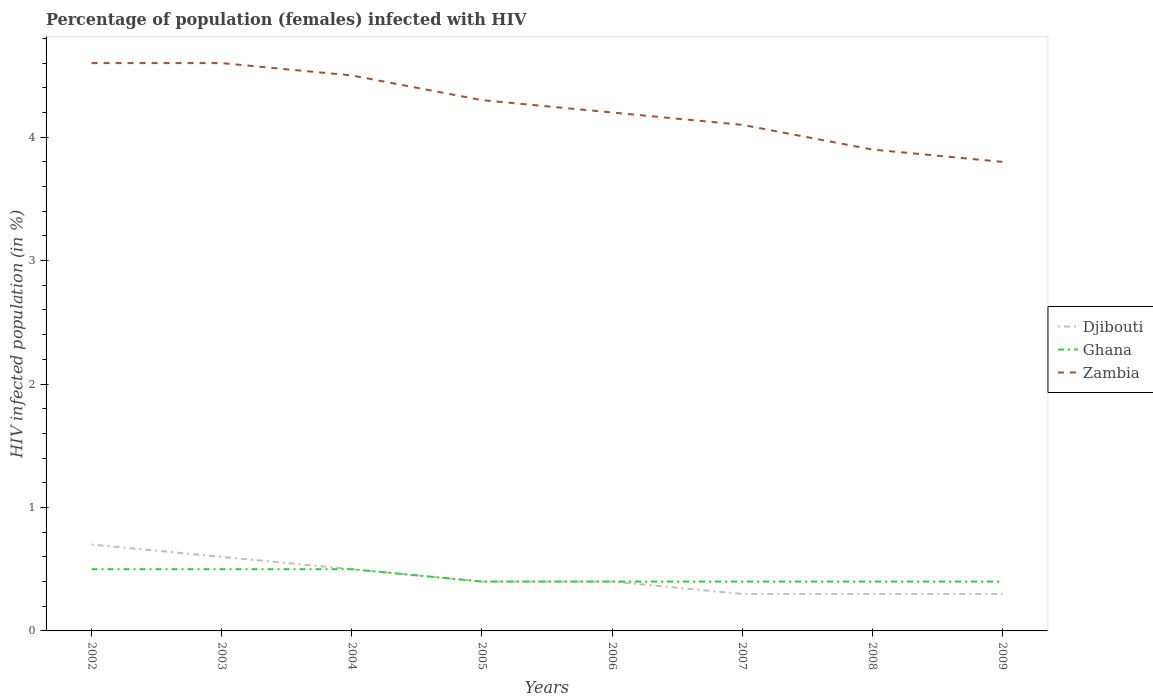How many different coloured lines are there?
Keep it short and to the point. 3. Across all years, what is the maximum percentage of HIV infected female population in Djibouti?
Offer a terse response. 0.3. What is the total percentage of HIV infected female population in Ghana in the graph?
Your response must be concise. 0. What is the difference between the highest and the second highest percentage of HIV infected female population in Djibouti?
Your answer should be very brief. 0.4. Is the percentage of HIV infected female population in Djibouti strictly greater than the percentage of HIV infected female population in Zambia over the years?
Offer a terse response. Yes. Are the values on the major ticks of Y-axis written in scientific E-notation?
Provide a short and direct response. No. What is the title of the graph?
Make the answer very short. Percentage of population (females) infected with HIV. Does "Kuwait" appear as one of the legend labels in the graph?
Make the answer very short. No. What is the label or title of the X-axis?
Give a very brief answer. Years. What is the label or title of the Y-axis?
Keep it short and to the point. HIV infected population (in %). What is the HIV infected population (in %) of Djibouti in 2002?
Your answer should be very brief. 0.7. What is the HIV infected population (in %) of Djibouti in 2003?
Provide a short and direct response. 0.6. What is the HIV infected population (in %) in Ghana in 2003?
Offer a terse response. 0.5. What is the HIV infected population (in %) of Ghana in 2004?
Ensure brevity in your answer.  0.5. What is the HIV infected population (in %) in Djibouti in 2005?
Give a very brief answer. 0.4. What is the HIV infected population (in %) of Ghana in 2006?
Keep it short and to the point. 0.4. What is the HIV infected population (in %) in Djibouti in 2007?
Offer a very short reply. 0.3. What is the HIV infected population (in %) in Ghana in 2007?
Keep it short and to the point. 0.4. What is the HIV infected population (in %) in Zambia in 2007?
Provide a short and direct response. 4.1. What is the HIV infected population (in %) of Djibouti in 2008?
Provide a short and direct response. 0.3. What is the HIV infected population (in %) of Djibouti in 2009?
Ensure brevity in your answer.  0.3. Across all years, what is the maximum HIV infected population (in %) of Djibouti?
Give a very brief answer. 0.7. Across all years, what is the maximum HIV infected population (in %) of Ghana?
Give a very brief answer. 0.5. Across all years, what is the minimum HIV infected population (in %) in Zambia?
Make the answer very short. 3.8. What is the total HIV infected population (in %) of Djibouti in the graph?
Offer a very short reply. 3.5. What is the total HIV infected population (in %) of Ghana in the graph?
Your answer should be very brief. 3.5. What is the total HIV infected population (in %) of Zambia in the graph?
Your answer should be compact. 34. What is the difference between the HIV infected population (in %) in Ghana in 2002 and that in 2003?
Give a very brief answer. 0. What is the difference between the HIV infected population (in %) of Zambia in 2002 and that in 2003?
Your response must be concise. 0. What is the difference between the HIV infected population (in %) in Ghana in 2002 and that in 2004?
Your response must be concise. 0. What is the difference between the HIV infected population (in %) in Zambia in 2002 and that in 2004?
Your answer should be compact. 0.1. What is the difference between the HIV infected population (in %) of Zambia in 2002 and that in 2005?
Ensure brevity in your answer.  0.3. What is the difference between the HIV infected population (in %) in Zambia in 2002 and that in 2006?
Offer a very short reply. 0.4. What is the difference between the HIV infected population (in %) of Djibouti in 2002 and that in 2008?
Give a very brief answer. 0.4. What is the difference between the HIV infected population (in %) in Ghana in 2002 and that in 2008?
Your response must be concise. 0.1. What is the difference between the HIV infected population (in %) of Zambia in 2002 and that in 2008?
Offer a very short reply. 0.7. What is the difference between the HIV infected population (in %) of Djibouti in 2002 and that in 2009?
Provide a succinct answer. 0.4. What is the difference between the HIV infected population (in %) of Ghana in 2002 and that in 2009?
Your answer should be compact. 0.1. What is the difference between the HIV infected population (in %) of Zambia in 2002 and that in 2009?
Your response must be concise. 0.8. What is the difference between the HIV infected population (in %) of Djibouti in 2003 and that in 2005?
Your answer should be very brief. 0.2. What is the difference between the HIV infected population (in %) in Djibouti in 2003 and that in 2006?
Offer a very short reply. 0.2. What is the difference between the HIV infected population (in %) in Zambia in 2003 and that in 2006?
Offer a very short reply. 0.4. What is the difference between the HIV infected population (in %) of Ghana in 2003 and that in 2007?
Provide a succinct answer. 0.1. What is the difference between the HIV infected population (in %) of Zambia in 2003 and that in 2007?
Make the answer very short. 0.5. What is the difference between the HIV infected population (in %) of Djibouti in 2003 and that in 2009?
Give a very brief answer. 0.3. What is the difference between the HIV infected population (in %) of Djibouti in 2004 and that in 2005?
Your answer should be compact. 0.1. What is the difference between the HIV infected population (in %) in Ghana in 2004 and that in 2005?
Your answer should be compact. 0.1. What is the difference between the HIV infected population (in %) of Zambia in 2004 and that in 2005?
Provide a succinct answer. 0.2. What is the difference between the HIV infected population (in %) in Djibouti in 2004 and that in 2006?
Make the answer very short. 0.1. What is the difference between the HIV infected population (in %) of Zambia in 2004 and that in 2006?
Give a very brief answer. 0.3. What is the difference between the HIV infected population (in %) of Zambia in 2004 and that in 2007?
Keep it short and to the point. 0.4. What is the difference between the HIV infected population (in %) of Ghana in 2004 and that in 2008?
Your answer should be compact. 0.1. What is the difference between the HIV infected population (in %) in Zambia in 2004 and that in 2008?
Provide a short and direct response. 0.6. What is the difference between the HIV infected population (in %) of Djibouti in 2005 and that in 2007?
Offer a very short reply. 0.1. What is the difference between the HIV infected population (in %) in Ghana in 2005 and that in 2007?
Make the answer very short. 0. What is the difference between the HIV infected population (in %) in Djibouti in 2005 and that in 2009?
Provide a short and direct response. 0.1. What is the difference between the HIV infected population (in %) of Ghana in 2005 and that in 2009?
Your response must be concise. 0. What is the difference between the HIV infected population (in %) in Djibouti in 2006 and that in 2007?
Your answer should be compact. 0.1. What is the difference between the HIV infected population (in %) in Ghana in 2006 and that in 2007?
Provide a short and direct response. 0. What is the difference between the HIV infected population (in %) in Djibouti in 2006 and that in 2008?
Your answer should be compact. 0.1. What is the difference between the HIV infected population (in %) in Ghana in 2006 and that in 2008?
Provide a succinct answer. 0. What is the difference between the HIV infected population (in %) in Zambia in 2006 and that in 2009?
Provide a short and direct response. 0.4. What is the difference between the HIV infected population (in %) of Djibouti in 2007 and that in 2008?
Provide a short and direct response. 0. What is the difference between the HIV infected population (in %) in Ghana in 2007 and that in 2009?
Make the answer very short. 0. What is the difference between the HIV infected population (in %) in Zambia in 2007 and that in 2009?
Your answer should be compact. 0.3. What is the difference between the HIV infected population (in %) of Djibouti in 2008 and that in 2009?
Your response must be concise. 0. What is the difference between the HIV infected population (in %) of Zambia in 2008 and that in 2009?
Your answer should be compact. 0.1. What is the difference between the HIV infected population (in %) in Ghana in 2002 and the HIV infected population (in %) in Zambia in 2003?
Offer a terse response. -4.1. What is the difference between the HIV infected population (in %) in Djibouti in 2002 and the HIV infected population (in %) in Zambia in 2004?
Offer a terse response. -3.8. What is the difference between the HIV infected population (in %) of Djibouti in 2002 and the HIV infected population (in %) of Zambia in 2005?
Provide a short and direct response. -3.6. What is the difference between the HIV infected population (in %) of Djibouti in 2002 and the HIV infected population (in %) of Ghana in 2006?
Make the answer very short. 0.3. What is the difference between the HIV infected population (in %) in Djibouti in 2002 and the HIV infected population (in %) in Zambia in 2006?
Offer a very short reply. -3.5. What is the difference between the HIV infected population (in %) in Ghana in 2002 and the HIV infected population (in %) in Zambia in 2006?
Provide a short and direct response. -3.7. What is the difference between the HIV infected population (in %) in Djibouti in 2002 and the HIV infected population (in %) in Ghana in 2007?
Keep it short and to the point. 0.3. What is the difference between the HIV infected population (in %) in Ghana in 2002 and the HIV infected population (in %) in Zambia in 2007?
Give a very brief answer. -3.6. What is the difference between the HIV infected population (in %) of Djibouti in 2002 and the HIV infected population (in %) of Zambia in 2009?
Provide a short and direct response. -3.1. What is the difference between the HIV infected population (in %) in Ghana in 2002 and the HIV infected population (in %) in Zambia in 2009?
Keep it short and to the point. -3.3. What is the difference between the HIV infected population (in %) of Djibouti in 2003 and the HIV infected population (in %) of Ghana in 2004?
Offer a terse response. 0.1. What is the difference between the HIV infected population (in %) of Ghana in 2003 and the HIV infected population (in %) of Zambia in 2004?
Offer a very short reply. -4. What is the difference between the HIV infected population (in %) in Djibouti in 2003 and the HIV infected population (in %) in Zambia in 2005?
Offer a very short reply. -3.7. What is the difference between the HIV infected population (in %) of Ghana in 2003 and the HIV infected population (in %) of Zambia in 2005?
Offer a terse response. -3.8. What is the difference between the HIV infected population (in %) in Djibouti in 2003 and the HIV infected population (in %) in Ghana in 2006?
Provide a succinct answer. 0.2. What is the difference between the HIV infected population (in %) of Ghana in 2003 and the HIV infected population (in %) of Zambia in 2006?
Your answer should be compact. -3.7. What is the difference between the HIV infected population (in %) in Djibouti in 2003 and the HIV infected population (in %) in Ghana in 2007?
Offer a terse response. 0.2. What is the difference between the HIV infected population (in %) of Djibouti in 2003 and the HIV infected population (in %) of Zambia in 2007?
Offer a very short reply. -3.5. What is the difference between the HIV infected population (in %) of Ghana in 2003 and the HIV infected population (in %) of Zambia in 2008?
Ensure brevity in your answer.  -3.4. What is the difference between the HIV infected population (in %) of Djibouti in 2003 and the HIV infected population (in %) of Zambia in 2009?
Provide a succinct answer. -3.2. What is the difference between the HIV infected population (in %) in Djibouti in 2004 and the HIV infected population (in %) in Ghana in 2005?
Offer a terse response. 0.1. What is the difference between the HIV infected population (in %) of Djibouti in 2004 and the HIV infected population (in %) of Zambia in 2005?
Ensure brevity in your answer.  -3.8. What is the difference between the HIV infected population (in %) of Ghana in 2004 and the HIV infected population (in %) of Zambia in 2005?
Make the answer very short. -3.8. What is the difference between the HIV infected population (in %) in Djibouti in 2004 and the HIV infected population (in %) in Ghana in 2006?
Ensure brevity in your answer.  0.1. What is the difference between the HIV infected population (in %) of Djibouti in 2004 and the HIV infected population (in %) of Ghana in 2007?
Give a very brief answer. 0.1. What is the difference between the HIV infected population (in %) of Djibouti in 2004 and the HIV infected population (in %) of Zambia in 2007?
Make the answer very short. -3.6. What is the difference between the HIV infected population (in %) in Djibouti in 2004 and the HIV infected population (in %) in Ghana in 2008?
Make the answer very short. 0.1. What is the difference between the HIV infected population (in %) in Ghana in 2004 and the HIV infected population (in %) in Zambia in 2008?
Make the answer very short. -3.4. What is the difference between the HIV infected population (in %) of Djibouti in 2004 and the HIV infected population (in %) of Zambia in 2009?
Offer a terse response. -3.3. What is the difference between the HIV infected population (in %) of Ghana in 2005 and the HIV infected population (in %) of Zambia in 2008?
Keep it short and to the point. -3.5. What is the difference between the HIV infected population (in %) in Djibouti in 2005 and the HIV infected population (in %) in Ghana in 2009?
Provide a short and direct response. 0. What is the difference between the HIV infected population (in %) of Djibouti in 2005 and the HIV infected population (in %) of Zambia in 2009?
Provide a short and direct response. -3.4. What is the difference between the HIV infected population (in %) in Ghana in 2005 and the HIV infected population (in %) in Zambia in 2009?
Provide a short and direct response. -3.4. What is the difference between the HIV infected population (in %) of Ghana in 2006 and the HIV infected population (in %) of Zambia in 2008?
Provide a succinct answer. -3.5. What is the difference between the HIV infected population (in %) of Djibouti in 2006 and the HIV infected population (in %) of Ghana in 2009?
Your answer should be very brief. 0. What is the difference between the HIV infected population (in %) in Djibouti in 2006 and the HIV infected population (in %) in Zambia in 2009?
Offer a terse response. -3.4. What is the difference between the HIV infected population (in %) of Ghana in 2007 and the HIV infected population (in %) of Zambia in 2008?
Offer a terse response. -3.5. What is the difference between the HIV infected population (in %) of Djibouti in 2007 and the HIV infected population (in %) of Zambia in 2009?
Your answer should be compact. -3.5. What is the difference between the HIV infected population (in %) of Ghana in 2007 and the HIV infected population (in %) of Zambia in 2009?
Make the answer very short. -3.4. What is the difference between the HIV infected population (in %) of Ghana in 2008 and the HIV infected population (in %) of Zambia in 2009?
Offer a very short reply. -3.4. What is the average HIV infected population (in %) in Djibouti per year?
Keep it short and to the point. 0.44. What is the average HIV infected population (in %) in Ghana per year?
Ensure brevity in your answer.  0.44. What is the average HIV infected population (in %) in Zambia per year?
Your answer should be compact. 4.25. In the year 2002, what is the difference between the HIV infected population (in %) in Djibouti and HIV infected population (in %) in Ghana?
Make the answer very short. 0.2. In the year 2003, what is the difference between the HIV infected population (in %) in Djibouti and HIV infected population (in %) in Zambia?
Keep it short and to the point. -4. In the year 2004, what is the difference between the HIV infected population (in %) of Ghana and HIV infected population (in %) of Zambia?
Your answer should be compact. -4. In the year 2005, what is the difference between the HIV infected population (in %) of Djibouti and HIV infected population (in %) of Zambia?
Your response must be concise. -3.9. In the year 2006, what is the difference between the HIV infected population (in %) of Ghana and HIV infected population (in %) of Zambia?
Your answer should be compact. -3.8. In the year 2007, what is the difference between the HIV infected population (in %) of Djibouti and HIV infected population (in %) of Ghana?
Provide a short and direct response. -0.1. In the year 2007, what is the difference between the HIV infected population (in %) in Ghana and HIV infected population (in %) in Zambia?
Ensure brevity in your answer.  -3.7. In the year 2008, what is the difference between the HIV infected population (in %) in Djibouti and HIV infected population (in %) in Zambia?
Offer a very short reply. -3.6. In the year 2008, what is the difference between the HIV infected population (in %) in Ghana and HIV infected population (in %) in Zambia?
Give a very brief answer. -3.5. In the year 2009, what is the difference between the HIV infected population (in %) of Djibouti and HIV infected population (in %) of Ghana?
Your answer should be compact. -0.1. In the year 2009, what is the difference between the HIV infected population (in %) in Djibouti and HIV infected population (in %) in Zambia?
Keep it short and to the point. -3.5. What is the ratio of the HIV infected population (in %) in Djibouti in 2002 to that in 2004?
Give a very brief answer. 1.4. What is the ratio of the HIV infected population (in %) in Zambia in 2002 to that in 2004?
Ensure brevity in your answer.  1.02. What is the ratio of the HIV infected population (in %) in Djibouti in 2002 to that in 2005?
Your answer should be very brief. 1.75. What is the ratio of the HIV infected population (in %) in Ghana in 2002 to that in 2005?
Offer a terse response. 1.25. What is the ratio of the HIV infected population (in %) in Zambia in 2002 to that in 2005?
Give a very brief answer. 1.07. What is the ratio of the HIV infected population (in %) of Djibouti in 2002 to that in 2006?
Keep it short and to the point. 1.75. What is the ratio of the HIV infected population (in %) in Zambia in 2002 to that in 2006?
Ensure brevity in your answer.  1.1. What is the ratio of the HIV infected population (in %) of Djibouti in 2002 to that in 2007?
Keep it short and to the point. 2.33. What is the ratio of the HIV infected population (in %) of Zambia in 2002 to that in 2007?
Give a very brief answer. 1.12. What is the ratio of the HIV infected population (in %) in Djibouti in 2002 to that in 2008?
Your response must be concise. 2.33. What is the ratio of the HIV infected population (in %) of Zambia in 2002 to that in 2008?
Provide a succinct answer. 1.18. What is the ratio of the HIV infected population (in %) of Djibouti in 2002 to that in 2009?
Make the answer very short. 2.33. What is the ratio of the HIV infected population (in %) of Ghana in 2002 to that in 2009?
Offer a terse response. 1.25. What is the ratio of the HIV infected population (in %) of Zambia in 2002 to that in 2009?
Offer a very short reply. 1.21. What is the ratio of the HIV infected population (in %) in Djibouti in 2003 to that in 2004?
Offer a very short reply. 1.2. What is the ratio of the HIV infected population (in %) of Zambia in 2003 to that in 2004?
Give a very brief answer. 1.02. What is the ratio of the HIV infected population (in %) in Ghana in 2003 to that in 2005?
Keep it short and to the point. 1.25. What is the ratio of the HIV infected population (in %) in Zambia in 2003 to that in 2005?
Keep it short and to the point. 1.07. What is the ratio of the HIV infected population (in %) of Djibouti in 2003 to that in 2006?
Ensure brevity in your answer.  1.5. What is the ratio of the HIV infected population (in %) of Ghana in 2003 to that in 2006?
Give a very brief answer. 1.25. What is the ratio of the HIV infected population (in %) of Zambia in 2003 to that in 2006?
Offer a very short reply. 1.1. What is the ratio of the HIV infected population (in %) of Djibouti in 2003 to that in 2007?
Make the answer very short. 2. What is the ratio of the HIV infected population (in %) in Ghana in 2003 to that in 2007?
Ensure brevity in your answer.  1.25. What is the ratio of the HIV infected population (in %) in Zambia in 2003 to that in 2007?
Give a very brief answer. 1.12. What is the ratio of the HIV infected population (in %) in Zambia in 2003 to that in 2008?
Give a very brief answer. 1.18. What is the ratio of the HIV infected population (in %) of Ghana in 2003 to that in 2009?
Your response must be concise. 1.25. What is the ratio of the HIV infected population (in %) in Zambia in 2003 to that in 2009?
Offer a very short reply. 1.21. What is the ratio of the HIV infected population (in %) of Djibouti in 2004 to that in 2005?
Ensure brevity in your answer.  1.25. What is the ratio of the HIV infected population (in %) in Ghana in 2004 to that in 2005?
Provide a succinct answer. 1.25. What is the ratio of the HIV infected population (in %) in Zambia in 2004 to that in 2005?
Your response must be concise. 1.05. What is the ratio of the HIV infected population (in %) of Djibouti in 2004 to that in 2006?
Your answer should be very brief. 1.25. What is the ratio of the HIV infected population (in %) of Ghana in 2004 to that in 2006?
Give a very brief answer. 1.25. What is the ratio of the HIV infected population (in %) of Zambia in 2004 to that in 2006?
Ensure brevity in your answer.  1.07. What is the ratio of the HIV infected population (in %) in Djibouti in 2004 to that in 2007?
Your response must be concise. 1.67. What is the ratio of the HIV infected population (in %) in Zambia in 2004 to that in 2007?
Keep it short and to the point. 1.1. What is the ratio of the HIV infected population (in %) in Djibouti in 2004 to that in 2008?
Keep it short and to the point. 1.67. What is the ratio of the HIV infected population (in %) of Zambia in 2004 to that in 2008?
Your answer should be compact. 1.15. What is the ratio of the HIV infected population (in %) of Djibouti in 2004 to that in 2009?
Offer a terse response. 1.67. What is the ratio of the HIV infected population (in %) in Zambia in 2004 to that in 2009?
Your answer should be very brief. 1.18. What is the ratio of the HIV infected population (in %) in Ghana in 2005 to that in 2006?
Provide a short and direct response. 1. What is the ratio of the HIV infected population (in %) in Zambia in 2005 to that in 2006?
Your answer should be very brief. 1.02. What is the ratio of the HIV infected population (in %) in Djibouti in 2005 to that in 2007?
Your answer should be very brief. 1.33. What is the ratio of the HIV infected population (in %) in Ghana in 2005 to that in 2007?
Ensure brevity in your answer.  1. What is the ratio of the HIV infected population (in %) of Zambia in 2005 to that in 2007?
Provide a short and direct response. 1.05. What is the ratio of the HIV infected population (in %) in Djibouti in 2005 to that in 2008?
Your response must be concise. 1.33. What is the ratio of the HIV infected population (in %) of Zambia in 2005 to that in 2008?
Offer a very short reply. 1.1. What is the ratio of the HIV infected population (in %) of Djibouti in 2005 to that in 2009?
Keep it short and to the point. 1.33. What is the ratio of the HIV infected population (in %) of Zambia in 2005 to that in 2009?
Provide a succinct answer. 1.13. What is the ratio of the HIV infected population (in %) of Djibouti in 2006 to that in 2007?
Your answer should be compact. 1.33. What is the ratio of the HIV infected population (in %) in Ghana in 2006 to that in 2007?
Offer a terse response. 1. What is the ratio of the HIV infected population (in %) of Zambia in 2006 to that in 2007?
Ensure brevity in your answer.  1.02. What is the ratio of the HIV infected population (in %) in Ghana in 2006 to that in 2008?
Offer a very short reply. 1. What is the ratio of the HIV infected population (in %) of Zambia in 2006 to that in 2008?
Offer a terse response. 1.08. What is the ratio of the HIV infected population (in %) in Djibouti in 2006 to that in 2009?
Your answer should be compact. 1.33. What is the ratio of the HIV infected population (in %) of Ghana in 2006 to that in 2009?
Your answer should be compact. 1. What is the ratio of the HIV infected population (in %) in Zambia in 2006 to that in 2009?
Provide a short and direct response. 1.11. What is the ratio of the HIV infected population (in %) of Zambia in 2007 to that in 2008?
Ensure brevity in your answer.  1.05. What is the ratio of the HIV infected population (in %) in Djibouti in 2007 to that in 2009?
Keep it short and to the point. 1. What is the ratio of the HIV infected population (in %) of Zambia in 2007 to that in 2009?
Keep it short and to the point. 1.08. What is the ratio of the HIV infected population (in %) of Djibouti in 2008 to that in 2009?
Give a very brief answer. 1. What is the ratio of the HIV infected population (in %) of Ghana in 2008 to that in 2009?
Keep it short and to the point. 1. What is the ratio of the HIV infected population (in %) of Zambia in 2008 to that in 2009?
Make the answer very short. 1.03. What is the difference between the highest and the second highest HIV infected population (in %) in Djibouti?
Ensure brevity in your answer.  0.1. What is the difference between the highest and the second highest HIV infected population (in %) of Ghana?
Offer a terse response. 0. What is the difference between the highest and the lowest HIV infected population (in %) of Djibouti?
Keep it short and to the point. 0.4. 